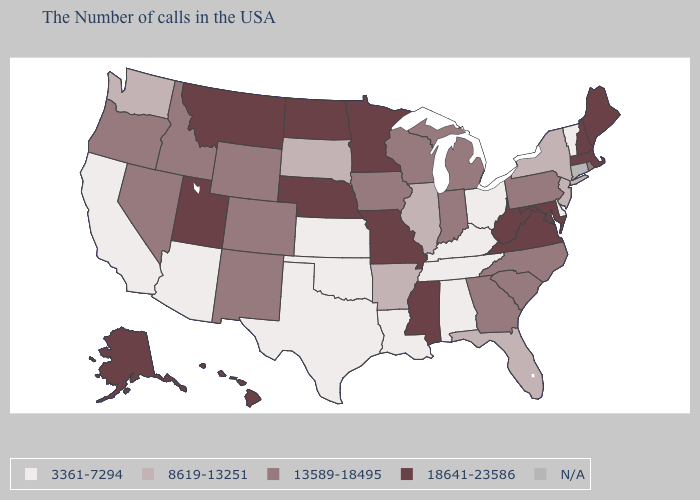What is the value of Vermont?
Short answer required. 3361-7294. Does California have the lowest value in the West?
Write a very short answer. Yes. What is the value of Montana?
Concise answer only. 18641-23586. What is the value of Indiana?
Be succinct. 13589-18495. What is the value of Washington?
Quick response, please. 8619-13251. Does the first symbol in the legend represent the smallest category?
Concise answer only. Yes. What is the highest value in states that border Delaware?
Quick response, please. 18641-23586. Does Pennsylvania have the highest value in the USA?
Quick response, please. No. Does Alaska have the highest value in the USA?
Quick response, please. Yes. Name the states that have a value in the range 13589-18495?
Short answer required. Rhode Island, Pennsylvania, North Carolina, South Carolina, Georgia, Michigan, Indiana, Wisconsin, Iowa, Wyoming, Colorado, New Mexico, Idaho, Nevada, Oregon. Name the states that have a value in the range N/A?
Answer briefly. Connecticut. Does Vermont have the lowest value in the Northeast?
Give a very brief answer. Yes. Does the first symbol in the legend represent the smallest category?
Quick response, please. Yes. Which states have the lowest value in the USA?
Be succinct. Vermont, Delaware, Ohio, Kentucky, Alabama, Tennessee, Louisiana, Kansas, Oklahoma, Texas, Arizona, California. Among the states that border Arkansas , which have the lowest value?
Answer briefly. Tennessee, Louisiana, Oklahoma, Texas. 